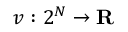Convert formula to latex. <formula><loc_0><loc_0><loc_500><loc_500>v \colon 2 ^ { N } \to R</formula> 